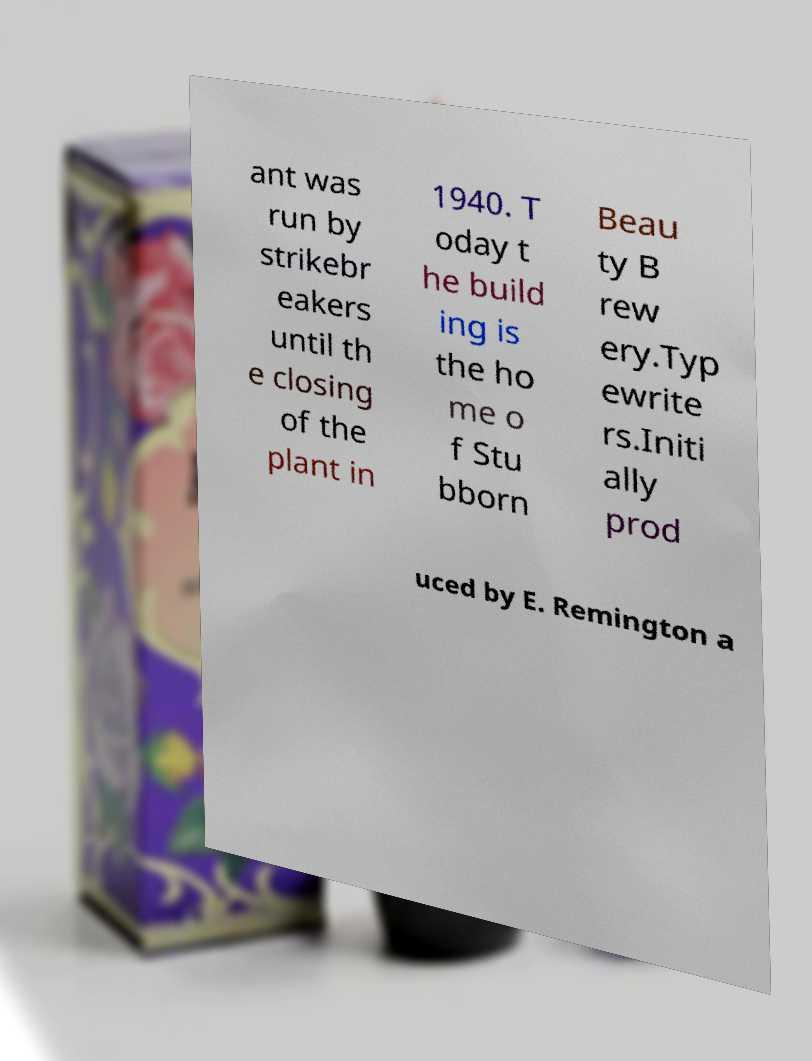I need the written content from this picture converted into text. Can you do that? ant was run by strikebr eakers until th e closing of the plant in 1940. T oday t he build ing is the ho me o f Stu bborn Beau ty B rew ery.Typ ewrite rs.Initi ally prod uced by E. Remington a 